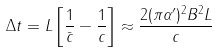<formula> <loc_0><loc_0><loc_500><loc_500>\Delta t = L \left [ \frac { 1 } { \bar { c } } - \frac { 1 } { c } \right ] \approx \frac { 2 ( \pi \alpha ^ { \prime } ) ^ { 2 } B ^ { 2 } L } { c }</formula> 